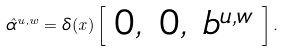Convert formula to latex. <formula><loc_0><loc_0><loc_500><loc_500>\hat { \alpha } ^ { u , w } = \delta ( x ) \left [ \begin{array} { c c c } 0 , & 0 , & b ^ { u , w } \end{array} \right ] .</formula> 